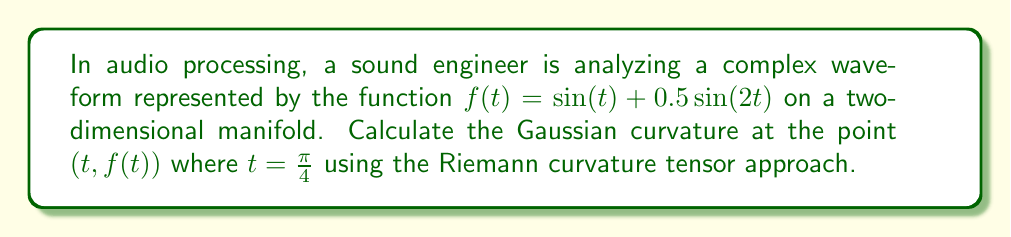Can you answer this question? To solve this problem, we'll follow these steps:

1) First, we need to parameterize the curve. Let's use:

   $x(t) = t$
   $y(t) = f(t) = \sin(t) + 0.5\sin(2t)$

2) Calculate the first and second derivatives:

   $x'(t) = 1$
   $y'(t) = f'(t) = \cos(t) + \cos(2t)$
   $x''(t) = 0$
   $y''(t) = f''(t) = -\sin(t) - 2\sin(2t)$

3) The metric tensor $g_{ij}$ for this parameterization is:

   $$g_{ij} = \begin{pmatrix} 1 & 0 \\ 0 & 1 \end{pmatrix}$$

4) The Christoffel symbols $\Gamma^k_{ij}$ are all zero for this metric.

5) The Riemann curvature tensor $R^i_{jkl}$ for a 2D manifold has only one independent component:

   $R^1_{212} = -R^1_{221} = -R^2_{112} = R^2_{121} = K$

   where $K$ is the Gaussian curvature.

6) For a curve in 2D, the Gaussian curvature is given by:

   $$K = \frac{x'y'' - x''y'}{(x'^2 + y'^2)^{3/2}}$$

7) Substituting our values at $t = \pi/4$:

   $x'(\pi/4) = 1$
   $y'(\pi/4) = \cos(\pi/4) + \cos(\pi/2) = \frac{\sqrt{2}}{2}$
   $x''(\pi/4) = 0$
   $y''(\pi/4) = -\sin(\pi/4) - 2\sin(\pi/2) = -\frac{\sqrt{2}}{2} - 2$

8) Now we can calculate K:

   $$K = \frac{1 \cdot (-\frac{\sqrt{2}}{2} - 2) - 0 \cdot \frac{\sqrt{2}}{2}}{(1^2 + (\frac{\sqrt{2}}{2})^2)^{3/2}}$$

   $$= \frac{-\frac{\sqrt{2}}{2} - 2}{(1 + \frac{1}{2})^{3/2}}$$

   $$= \frac{-\frac{\sqrt{2}}{2} - 2}{(\frac{3}{2})^{3/2}}$$

   $$= -\frac{2\sqrt{2} + 4}{3\sqrt{3}}$$
Answer: $K = -\frac{2\sqrt{2} + 4}{3\sqrt{3}}$ 